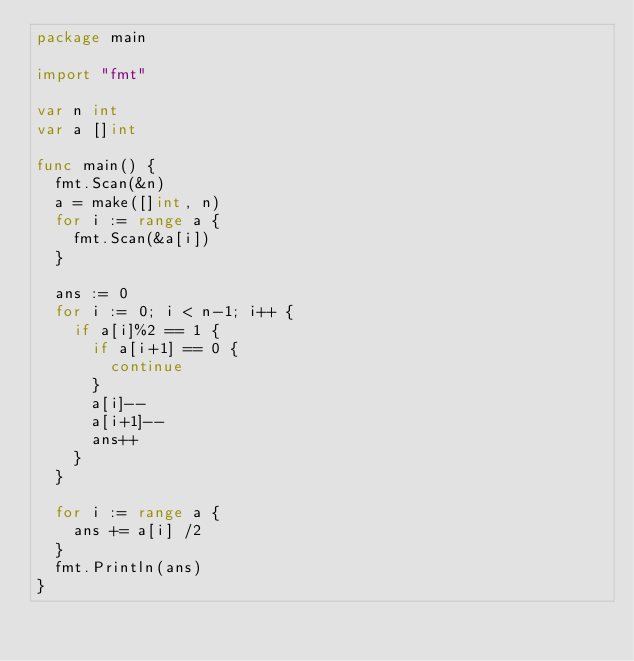Convert code to text. <code><loc_0><loc_0><loc_500><loc_500><_Go_>package main

import "fmt"

var n int
var a []int

func main() {
	fmt.Scan(&n)
	a = make([]int, n)
	for i := range a {
		fmt.Scan(&a[i])
	}

	ans := 0
	for i := 0; i < n-1; i++ {
		if a[i]%2 == 1 {
			if a[i+1] == 0 {
				continue
			}
			a[i]--
			a[i+1]--
			ans++
		}
	}

	for i := range a {
		ans += a[i] /2
	}
	fmt.Println(ans)
}
</code> 